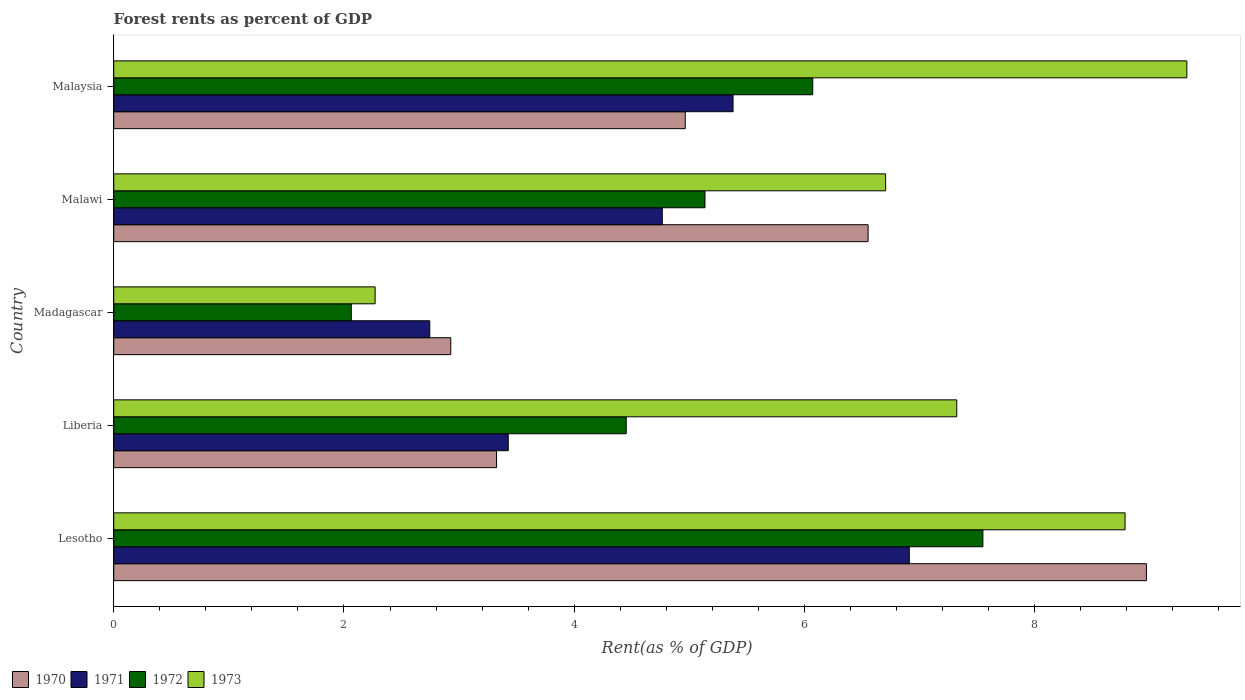How many different coloured bars are there?
Provide a succinct answer. 4. Are the number of bars on each tick of the Y-axis equal?
Make the answer very short. Yes. How many bars are there on the 1st tick from the bottom?
Make the answer very short. 4. What is the label of the 3rd group of bars from the top?
Make the answer very short. Madagascar. In how many cases, is the number of bars for a given country not equal to the number of legend labels?
Make the answer very short. 0. What is the forest rent in 1970 in Liberia?
Give a very brief answer. 3.33. Across all countries, what is the maximum forest rent in 1971?
Make the answer very short. 6.91. Across all countries, what is the minimum forest rent in 1973?
Offer a very short reply. 2.27. In which country was the forest rent in 1973 maximum?
Make the answer very short. Malaysia. In which country was the forest rent in 1973 minimum?
Make the answer very short. Madagascar. What is the total forest rent in 1973 in the graph?
Your response must be concise. 34.41. What is the difference between the forest rent in 1972 in Madagascar and that in Malaysia?
Your answer should be very brief. -4.01. What is the difference between the forest rent in 1973 in Malaysia and the forest rent in 1972 in Lesotho?
Give a very brief answer. 1.77. What is the average forest rent in 1972 per country?
Keep it short and to the point. 5.05. What is the difference between the forest rent in 1970 and forest rent in 1973 in Lesotho?
Your response must be concise. 0.19. What is the ratio of the forest rent in 1970 in Lesotho to that in Liberia?
Your response must be concise. 2.7. Is the difference between the forest rent in 1970 in Madagascar and Malawi greater than the difference between the forest rent in 1973 in Madagascar and Malawi?
Your answer should be very brief. Yes. What is the difference between the highest and the second highest forest rent in 1971?
Offer a very short reply. 1.53. What is the difference between the highest and the lowest forest rent in 1973?
Offer a terse response. 7.05. In how many countries, is the forest rent in 1971 greater than the average forest rent in 1971 taken over all countries?
Provide a succinct answer. 3. Is it the case that in every country, the sum of the forest rent in 1973 and forest rent in 1970 is greater than the sum of forest rent in 1971 and forest rent in 1972?
Your response must be concise. No. What does the 3rd bar from the bottom in Madagascar represents?
Provide a short and direct response. 1972. How many bars are there?
Ensure brevity in your answer.  20. What is the difference between two consecutive major ticks on the X-axis?
Give a very brief answer. 2. Where does the legend appear in the graph?
Your response must be concise. Bottom left. How are the legend labels stacked?
Provide a succinct answer. Horizontal. What is the title of the graph?
Your response must be concise. Forest rents as percent of GDP. Does "1968" appear as one of the legend labels in the graph?
Offer a very short reply. No. What is the label or title of the X-axis?
Offer a very short reply. Rent(as % of GDP). What is the label or title of the Y-axis?
Your answer should be compact. Country. What is the Rent(as % of GDP) in 1970 in Lesotho?
Your answer should be compact. 8.97. What is the Rent(as % of GDP) in 1971 in Lesotho?
Give a very brief answer. 6.91. What is the Rent(as % of GDP) in 1972 in Lesotho?
Provide a short and direct response. 7.55. What is the Rent(as % of GDP) of 1973 in Lesotho?
Ensure brevity in your answer.  8.79. What is the Rent(as % of GDP) in 1970 in Liberia?
Offer a very short reply. 3.33. What is the Rent(as % of GDP) of 1971 in Liberia?
Provide a short and direct response. 3.43. What is the Rent(as % of GDP) of 1972 in Liberia?
Provide a short and direct response. 4.45. What is the Rent(as % of GDP) of 1973 in Liberia?
Offer a terse response. 7.32. What is the Rent(as % of GDP) of 1970 in Madagascar?
Provide a succinct answer. 2.93. What is the Rent(as % of GDP) of 1971 in Madagascar?
Your answer should be compact. 2.75. What is the Rent(as % of GDP) of 1972 in Madagascar?
Ensure brevity in your answer.  2.06. What is the Rent(as % of GDP) of 1973 in Madagascar?
Your response must be concise. 2.27. What is the Rent(as % of GDP) in 1970 in Malawi?
Make the answer very short. 6.55. What is the Rent(as % of GDP) in 1971 in Malawi?
Your response must be concise. 4.77. What is the Rent(as % of GDP) of 1972 in Malawi?
Ensure brevity in your answer.  5.14. What is the Rent(as % of GDP) of 1973 in Malawi?
Provide a short and direct response. 6.71. What is the Rent(as % of GDP) of 1970 in Malaysia?
Provide a succinct answer. 4.96. What is the Rent(as % of GDP) of 1971 in Malaysia?
Give a very brief answer. 5.38. What is the Rent(as % of GDP) in 1972 in Malaysia?
Provide a short and direct response. 6.07. What is the Rent(as % of GDP) in 1973 in Malaysia?
Offer a terse response. 9.32. Across all countries, what is the maximum Rent(as % of GDP) in 1970?
Your answer should be very brief. 8.97. Across all countries, what is the maximum Rent(as % of GDP) of 1971?
Give a very brief answer. 6.91. Across all countries, what is the maximum Rent(as % of GDP) in 1972?
Give a very brief answer. 7.55. Across all countries, what is the maximum Rent(as % of GDP) of 1973?
Ensure brevity in your answer.  9.32. Across all countries, what is the minimum Rent(as % of GDP) of 1970?
Give a very brief answer. 2.93. Across all countries, what is the minimum Rent(as % of GDP) of 1971?
Your answer should be compact. 2.75. Across all countries, what is the minimum Rent(as % of GDP) of 1972?
Ensure brevity in your answer.  2.06. Across all countries, what is the minimum Rent(as % of GDP) in 1973?
Provide a short and direct response. 2.27. What is the total Rent(as % of GDP) of 1970 in the graph?
Ensure brevity in your answer.  26.74. What is the total Rent(as % of GDP) of 1971 in the graph?
Ensure brevity in your answer.  23.23. What is the total Rent(as % of GDP) of 1972 in the graph?
Keep it short and to the point. 25.27. What is the total Rent(as % of GDP) of 1973 in the graph?
Your answer should be compact. 34.41. What is the difference between the Rent(as % of GDP) of 1970 in Lesotho and that in Liberia?
Provide a succinct answer. 5.65. What is the difference between the Rent(as % of GDP) of 1971 in Lesotho and that in Liberia?
Give a very brief answer. 3.48. What is the difference between the Rent(as % of GDP) in 1972 in Lesotho and that in Liberia?
Your answer should be very brief. 3.1. What is the difference between the Rent(as % of GDP) of 1973 in Lesotho and that in Liberia?
Offer a terse response. 1.46. What is the difference between the Rent(as % of GDP) in 1970 in Lesotho and that in Madagascar?
Your response must be concise. 6.04. What is the difference between the Rent(as % of GDP) in 1971 in Lesotho and that in Madagascar?
Give a very brief answer. 4.17. What is the difference between the Rent(as % of GDP) of 1972 in Lesotho and that in Madagascar?
Offer a terse response. 5.49. What is the difference between the Rent(as % of GDP) of 1973 in Lesotho and that in Madagascar?
Provide a succinct answer. 6.51. What is the difference between the Rent(as % of GDP) of 1970 in Lesotho and that in Malawi?
Ensure brevity in your answer.  2.42. What is the difference between the Rent(as % of GDP) of 1971 in Lesotho and that in Malawi?
Give a very brief answer. 2.15. What is the difference between the Rent(as % of GDP) in 1972 in Lesotho and that in Malawi?
Your response must be concise. 2.41. What is the difference between the Rent(as % of GDP) in 1973 in Lesotho and that in Malawi?
Offer a terse response. 2.08. What is the difference between the Rent(as % of GDP) of 1970 in Lesotho and that in Malaysia?
Give a very brief answer. 4.01. What is the difference between the Rent(as % of GDP) in 1971 in Lesotho and that in Malaysia?
Offer a very short reply. 1.53. What is the difference between the Rent(as % of GDP) in 1972 in Lesotho and that in Malaysia?
Provide a succinct answer. 1.48. What is the difference between the Rent(as % of GDP) of 1973 in Lesotho and that in Malaysia?
Make the answer very short. -0.54. What is the difference between the Rent(as % of GDP) of 1970 in Liberia and that in Madagascar?
Your response must be concise. 0.4. What is the difference between the Rent(as % of GDP) in 1971 in Liberia and that in Madagascar?
Your answer should be compact. 0.68. What is the difference between the Rent(as % of GDP) in 1972 in Liberia and that in Madagascar?
Offer a very short reply. 2.39. What is the difference between the Rent(as % of GDP) of 1973 in Liberia and that in Madagascar?
Provide a short and direct response. 5.05. What is the difference between the Rent(as % of GDP) of 1970 in Liberia and that in Malawi?
Your response must be concise. -3.23. What is the difference between the Rent(as % of GDP) in 1971 in Liberia and that in Malawi?
Ensure brevity in your answer.  -1.34. What is the difference between the Rent(as % of GDP) in 1972 in Liberia and that in Malawi?
Provide a succinct answer. -0.68. What is the difference between the Rent(as % of GDP) in 1973 in Liberia and that in Malawi?
Your response must be concise. 0.62. What is the difference between the Rent(as % of GDP) in 1970 in Liberia and that in Malaysia?
Give a very brief answer. -1.64. What is the difference between the Rent(as % of GDP) in 1971 in Liberia and that in Malaysia?
Give a very brief answer. -1.95. What is the difference between the Rent(as % of GDP) in 1972 in Liberia and that in Malaysia?
Keep it short and to the point. -1.62. What is the difference between the Rent(as % of GDP) of 1973 in Liberia and that in Malaysia?
Provide a succinct answer. -2. What is the difference between the Rent(as % of GDP) of 1970 in Madagascar and that in Malawi?
Keep it short and to the point. -3.63. What is the difference between the Rent(as % of GDP) of 1971 in Madagascar and that in Malawi?
Your answer should be compact. -2.02. What is the difference between the Rent(as % of GDP) of 1972 in Madagascar and that in Malawi?
Offer a very short reply. -3.07. What is the difference between the Rent(as % of GDP) of 1973 in Madagascar and that in Malawi?
Your answer should be very brief. -4.43. What is the difference between the Rent(as % of GDP) in 1970 in Madagascar and that in Malaysia?
Your answer should be compact. -2.04. What is the difference between the Rent(as % of GDP) in 1971 in Madagascar and that in Malaysia?
Ensure brevity in your answer.  -2.63. What is the difference between the Rent(as % of GDP) in 1972 in Madagascar and that in Malaysia?
Provide a succinct answer. -4.01. What is the difference between the Rent(as % of GDP) of 1973 in Madagascar and that in Malaysia?
Your answer should be compact. -7.05. What is the difference between the Rent(as % of GDP) in 1970 in Malawi and that in Malaysia?
Provide a succinct answer. 1.59. What is the difference between the Rent(as % of GDP) in 1971 in Malawi and that in Malaysia?
Keep it short and to the point. -0.61. What is the difference between the Rent(as % of GDP) of 1972 in Malawi and that in Malaysia?
Offer a very short reply. -0.94. What is the difference between the Rent(as % of GDP) in 1973 in Malawi and that in Malaysia?
Offer a very short reply. -2.62. What is the difference between the Rent(as % of GDP) in 1970 in Lesotho and the Rent(as % of GDP) in 1971 in Liberia?
Offer a terse response. 5.54. What is the difference between the Rent(as % of GDP) of 1970 in Lesotho and the Rent(as % of GDP) of 1972 in Liberia?
Give a very brief answer. 4.52. What is the difference between the Rent(as % of GDP) of 1970 in Lesotho and the Rent(as % of GDP) of 1973 in Liberia?
Give a very brief answer. 1.65. What is the difference between the Rent(as % of GDP) in 1971 in Lesotho and the Rent(as % of GDP) in 1972 in Liberia?
Make the answer very short. 2.46. What is the difference between the Rent(as % of GDP) of 1971 in Lesotho and the Rent(as % of GDP) of 1973 in Liberia?
Keep it short and to the point. -0.41. What is the difference between the Rent(as % of GDP) of 1972 in Lesotho and the Rent(as % of GDP) of 1973 in Liberia?
Offer a terse response. 0.23. What is the difference between the Rent(as % of GDP) in 1970 in Lesotho and the Rent(as % of GDP) in 1971 in Madagascar?
Offer a very short reply. 6.23. What is the difference between the Rent(as % of GDP) of 1970 in Lesotho and the Rent(as % of GDP) of 1972 in Madagascar?
Offer a terse response. 6.91. What is the difference between the Rent(as % of GDP) in 1970 in Lesotho and the Rent(as % of GDP) in 1973 in Madagascar?
Give a very brief answer. 6.7. What is the difference between the Rent(as % of GDP) of 1971 in Lesotho and the Rent(as % of GDP) of 1972 in Madagascar?
Offer a very short reply. 4.85. What is the difference between the Rent(as % of GDP) of 1971 in Lesotho and the Rent(as % of GDP) of 1973 in Madagascar?
Offer a terse response. 4.64. What is the difference between the Rent(as % of GDP) in 1972 in Lesotho and the Rent(as % of GDP) in 1973 in Madagascar?
Provide a short and direct response. 5.28. What is the difference between the Rent(as % of GDP) of 1970 in Lesotho and the Rent(as % of GDP) of 1971 in Malawi?
Ensure brevity in your answer.  4.21. What is the difference between the Rent(as % of GDP) in 1970 in Lesotho and the Rent(as % of GDP) in 1972 in Malawi?
Offer a terse response. 3.83. What is the difference between the Rent(as % of GDP) of 1970 in Lesotho and the Rent(as % of GDP) of 1973 in Malawi?
Your response must be concise. 2.27. What is the difference between the Rent(as % of GDP) in 1971 in Lesotho and the Rent(as % of GDP) in 1972 in Malawi?
Provide a short and direct response. 1.78. What is the difference between the Rent(as % of GDP) in 1971 in Lesotho and the Rent(as % of GDP) in 1973 in Malawi?
Offer a very short reply. 0.21. What is the difference between the Rent(as % of GDP) in 1972 in Lesotho and the Rent(as % of GDP) in 1973 in Malawi?
Keep it short and to the point. 0.85. What is the difference between the Rent(as % of GDP) of 1970 in Lesotho and the Rent(as % of GDP) of 1971 in Malaysia?
Offer a terse response. 3.59. What is the difference between the Rent(as % of GDP) of 1970 in Lesotho and the Rent(as % of GDP) of 1972 in Malaysia?
Your answer should be compact. 2.9. What is the difference between the Rent(as % of GDP) of 1970 in Lesotho and the Rent(as % of GDP) of 1973 in Malaysia?
Offer a terse response. -0.35. What is the difference between the Rent(as % of GDP) in 1971 in Lesotho and the Rent(as % of GDP) in 1972 in Malaysia?
Provide a succinct answer. 0.84. What is the difference between the Rent(as % of GDP) in 1971 in Lesotho and the Rent(as % of GDP) in 1973 in Malaysia?
Offer a very short reply. -2.41. What is the difference between the Rent(as % of GDP) in 1972 in Lesotho and the Rent(as % of GDP) in 1973 in Malaysia?
Your response must be concise. -1.77. What is the difference between the Rent(as % of GDP) of 1970 in Liberia and the Rent(as % of GDP) of 1971 in Madagascar?
Ensure brevity in your answer.  0.58. What is the difference between the Rent(as % of GDP) in 1970 in Liberia and the Rent(as % of GDP) in 1972 in Madagascar?
Give a very brief answer. 1.26. What is the difference between the Rent(as % of GDP) in 1970 in Liberia and the Rent(as % of GDP) in 1973 in Madagascar?
Provide a short and direct response. 1.05. What is the difference between the Rent(as % of GDP) in 1971 in Liberia and the Rent(as % of GDP) in 1972 in Madagascar?
Give a very brief answer. 1.36. What is the difference between the Rent(as % of GDP) in 1971 in Liberia and the Rent(as % of GDP) in 1973 in Madagascar?
Provide a succinct answer. 1.16. What is the difference between the Rent(as % of GDP) in 1972 in Liberia and the Rent(as % of GDP) in 1973 in Madagascar?
Offer a very short reply. 2.18. What is the difference between the Rent(as % of GDP) in 1970 in Liberia and the Rent(as % of GDP) in 1971 in Malawi?
Offer a terse response. -1.44. What is the difference between the Rent(as % of GDP) in 1970 in Liberia and the Rent(as % of GDP) in 1972 in Malawi?
Your response must be concise. -1.81. What is the difference between the Rent(as % of GDP) in 1970 in Liberia and the Rent(as % of GDP) in 1973 in Malawi?
Your response must be concise. -3.38. What is the difference between the Rent(as % of GDP) in 1971 in Liberia and the Rent(as % of GDP) in 1972 in Malawi?
Your response must be concise. -1.71. What is the difference between the Rent(as % of GDP) of 1971 in Liberia and the Rent(as % of GDP) of 1973 in Malawi?
Make the answer very short. -3.28. What is the difference between the Rent(as % of GDP) of 1972 in Liberia and the Rent(as % of GDP) of 1973 in Malawi?
Your answer should be very brief. -2.25. What is the difference between the Rent(as % of GDP) of 1970 in Liberia and the Rent(as % of GDP) of 1971 in Malaysia?
Your answer should be very brief. -2.05. What is the difference between the Rent(as % of GDP) in 1970 in Liberia and the Rent(as % of GDP) in 1972 in Malaysia?
Your answer should be very brief. -2.75. What is the difference between the Rent(as % of GDP) in 1970 in Liberia and the Rent(as % of GDP) in 1973 in Malaysia?
Provide a short and direct response. -6. What is the difference between the Rent(as % of GDP) of 1971 in Liberia and the Rent(as % of GDP) of 1972 in Malaysia?
Your answer should be very brief. -2.65. What is the difference between the Rent(as % of GDP) of 1971 in Liberia and the Rent(as % of GDP) of 1973 in Malaysia?
Provide a succinct answer. -5.89. What is the difference between the Rent(as % of GDP) of 1972 in Liberia and the Rent(as % of GDP) of 1973 in Malaysia?
Ensure brevity in your answer.  -4.87. What is the difference between the Rent(as % of GDP) in 1970 in Madagascar and the Rent(as % of GDP) in 1971 in Malawi?
Ensure brevity in your answer.  -1.84. What is the difference between the Rent(as % of GDP) of 1970 in Madagascar and the Rent(as % of GDP) of 1972 in Malawi?
Your response must be concise. -2.21. What is the difference between the Rent(as % of GDP) of 1970 in Madagascar and the Rent(as % of GDP) of 1973 in Malawi?
Keep it short and to the point. -3.78. What is the difference between the Rent(as % of GDP) of 1971 in Madagascar and the Rent(as % of GDP) of 1972 in Malawi?
Provide a succinct answer. -2.39. What is the difference between the Rent(as % of GDP) in 1971 in Madagascar and the Rent(as % of GDP) in 1973 in Malawi?
Ensure brevity in your answer.  -3.96. What is the difference between the Rent(as % of GDP) in 1972 in Madagascar and the Rent(as % of GDP) in 1973 in Malawi?
Give a very brief answer. -4.64. What is the difference between the Rent(as % of GDP) in 1970 in Madagascar and the Rent(as % of GDP) in 1971 in Malaysia?
Your response must be concise. -2.45. What is the difference between the Rent(as % of GDP) of 1970 in Madagascar and the Rent(as % of GDP) of 1972 in Malaysia?
Your response must be concise. -3.14. What is the difference between the Rent(as % of GDP) in 1970 in Madagascar and the Rent(as % of GDP) in 1973 in Malaysia?
Ensure brevity in your answer.  -6.39. What is the difference between the Rent(as % of GDP) of 1971 in Madagascar and the Rent(as % of GDP) of 1972 in Malaysia?
Offer a very short reply. -3.33. What is the difference between the Rent(as % of GDP) of 1971 in Madagascar and the Rent(as % of GDP) of 1973 in Malaysia?
Ensure brevity in your answer.  -6.58. What is the difference between the Rent(as % of GDP) of 1972 in Madagascar and the Rent(as % of GDP) of 1973 in Malaysia?
Your response must be concise. -7.26. What is the difference between the Rent(as % of GDP) in 1970 in Malawi and the Rent(as % of GDP) in 1971 in Malaysia?
Keep it short and to the point. 1.17. What is the difference between the Rent(as % of GDP) in 1970 in Malawi and the Rent(as % of GDP) in 1972 in Malaysia?
Offer a terse response. 0.48. What is the difference between the Rent(as % of GDP) of 1970 in Malawi and the Rent(as % of GDP) of 1973 in Malaysia?
Provide a succinct answer. -2.77. What is the difference between the Rent(as % of GDP) of 1971 in Malawi and the Rent(as % of GDP) of 1972 in Malaysia?
Your answer should be very brief. -1.31. What is the difference between the Rent(as % of GDP) in 1971 in Malawi and the Rent(as % of GDP) in 1973 in Malaysia?
Offer a terse response. -4.56. What is the difference between the Rent(as % of GDP) in 1972 in Malawi and the Rent(as % of GDP) in 1973 in Malaysia?
Provide a succinct answer. -4.19. What is the average Rent(as % of GDP) of 1970 per country?
Provide a succinct answer. 5.35. What is the average Rent(as % of GDP) in 1971 per country?
Keep it short and to the point. 4.65. What is the average Rent(as % of GDP) of 1972 per country?
Provide a short and direct response. 5.05. What is the average Rent(as % of GDP) of 1973 per country?
Make the answer very short. 6.88. What is the difference between the Rent(as % of GDP) of 1970 and Rent(as % of GDP) of 1971 in Lesotho?
Your answer should be compact. 2.06. What is the difference between the Rent(as % of GDP) in 1970 and Rent(as % of GDP) in 1972 in Lesotho?
Give a very brief answer. 1.42. What is the difference between the Rent(as % of GDP) in 1970 and Rent(as % of GDP) in 1973 in Lesotho?
Your response must be concise. 0.19. What is the difference between the Rent(as % of GDP) in 1971 and Rent(as % of GDP) in 1972 in Lesotho?
Make the answer very short. -0.64. What is the difference between the Rent(as % of GDP) in 1971 and Rent(as % of GDP) in 1973 in Lesotho?
Provide a succinct answer. -1.87. What is the difference between the Rent(as % of GDP) in 1972 and Rent(as % of GDP) in 1973 in Lesotho?
Provide a succinct answer. -1.24. What is the difference between the Rent(as % of GDP) of 1970 and Rent(as % of GDP) of 1971 in Liberia?
Your answer should be compact. -0.1. What is the difference between the Rent(as % of GDP) of 1970 and Rent(as % of GDP) of 1972 in Liberia?
Keep it short and to the point. -1.13. What is the difference between the Rent(as % of GDP) of 1970 and Rent(as % of GDP) of 1973 in Liberia?
Offer a terse response. -4. What is the difference between the Rent(as % of GDP) of 1971 and Rent(as % of GDP) of 1972 in Liberia?
Make the answer very short. -1.02. What is the difference between the Rent(as % of GDP) in 1971 and Rent(as % of GDP) in 1973 in Liberia?
Your answer should be compact. -3.9. What is the difference between the Rent(as % of GDP) of 1972 and Rent(as % of GDP) of 1973 in Liberia?
Your answer should be compact. -2.87. What is the difference between the Rent(as % of GDP) in 1970 and Rent(as % of GDP) in 1971 in Madagascar?
Your answer should be very brief. 0.18. What is the difference between the Rent(as % of GDP) of 1970 and Rent(as % of GDP) of 1972 in Madagascar?
Offer a very short reply. 0.86. What is the difference between the Rent(as % of GDP) of 1970 and Rent(as % of GDP) of 1973 in Madagascar?
Ensure brevity in your answer.  0.66. What is the difference between the Rent(as % of GDP) of 1971 and Rent(as % of GDP) of 1972 in Madagascar?
Provide a short and direct response. 0.68. What is the difference between the Rent(as % of GDP) of 1971 and Rent(as % of GDP) of 1973 in Madagascar?
Keep it short and to the point. 0.47. What is the difference between the Rent(as % of GDP) of 1972 and Rent(as % of GDP) of 1973 in Madagascar?
Provide a succinct answer. -0.21. What is the difference between the Rent(as % of GDP) in 1970 and Rent(as % of GDP) in 1971 in Malawi?
Make the answer very short. 1.79. What is the difference between the Rent(as % of GDP) of 1970 and Rent(as % of GDP) of 1972 in Malawi?
Provide a succinct answer. 1.42. What is the difference between the Rent(as % of GDP) of 1970 and Rent(as % of GDP) of 1973 in Malawi?
Offer a very short reply. -0.15. What is the difference between the Rent(as % of GDP) of 1971 and Rent(as % of GDP) of 1972 in Malawi?
Your answer should be compact. -0.37. What is the difference between the Rent(as % of GDP) of 1971 and Rent(as % of GDP) of 1973 in Malawi?
Offer a terse response. -1.94. What is the difference between the Rent(as % of GDP) in 1972 and Rent(as % of GDP) in 1973 in Malawi?
Give a very brief answer. -1.57. What is the difference between the Rent(as % of GDP) in 1970 and Rent(as % of GDP) in 1971 in Malaysia?
Your answer should be very brief. -0.42. What is the difference between the Rent(as % of GDP) of 1970 and Rent(as % of GDP) of 1972 in Malaysia?
Your answer should be very brief. -1.11. What is the difference between the Rent(as % of GDP) in 1970 and Rent(as % of GDP) in 1973 in Malaysia?
Provide a short and direct response. -4.36. What is the difference between the Rent(as % of GDP) in 1971 and Rent(as % of GDP) in 1972 in Malaysia?
Your response must be concise. -0.69. What is the difference between the Rent(as % of GDP) of 1971 and Rent(as % of GDP) of 1973 in Malaysia?
Keep it short and to the point. -3.94. What is the difference between the Rent(as % of GDP) in 1972 and Rent(as % of GDP) in 1973 in Malaysia?
Provide a succinct answer. -3.25. What is the ratio of the Rent(as % of GDP) of 1970 in Lesotho to that in Liberia?
Your response must be concise. 2.7. What is the ratio of the Rent(as % of GDP) of 1971 in Lesotho to that in Liberia?
Ensure brevity in your answer.  2.02. What is the ratio of the Rent(as % of GDP) in 1972 in Lesotho to that in Liberia?
Ensure brevity in your answer.  1.7. What is the ratio of the Rent(as % of GDP) in 1973 in Lesotho to that in Liberia?
Your response must be concise. 1.2. What is the ratio of the Rent(as % of GDP) of 1970 in Lesotho to that in Madagascar?
Make the answer very short. 3.06. What is the ratio of the Rent(as % of GDP) of 1971 in Lesotho to that in Madagascar?
Give a very brief answer. 2.52. What is the ratio of the Rent(as % of GDP) in 1972 in Lesotho to that in Madagascar?
Make the answer very short. 3.66. What is the ratio of the Rent(as % of GDP) of 1973 in Lesotho to that in Madagascar?
Your answer should be compact. 3.87. What is the ratio of the Rent(as % of GDP) in 1970 in Lesotho to that in Malawi?
Ensure brevity in your answer.  1.37. What is the ratio of the Rent(as % of GDP) in 1971 in Lesotho to that in Malawi?
Provide a succinct answer. 1.45. What is the ratio of the Rent(as % of GDP) of 1972 in Lesotho to that in Malawi?
Provide a succinct answer. 1.47. What is the ratio of the Rent(as % of GDP) in 1973 in Lesotho to that in Malawi?
Provide a succinct answer. 1.31. What is the ratio of the Rent(as % of GDP) in 1970 in Lesotho to that in Malaysia?
Make the answer very short. 1.81. What is the ratio of the Rent(as % of GDP) of 1971 in Lesotho to that in Malaysia?
Give a very brief answer. 1.28. What is the ratio of the Rent(as % of GDP) of 1972 in Lesotho to that in Malaysia?
Your answer should be compact. 1.24. What is the ratio of the Rent(as % of GDP) in 1973 in Lesotho to that in Malaysia?
Your answer should be compact. 0.94. What is the ratio of the Rent(as % of GDP) of 1970 in Liberia to that in Madagascar?
Provide a short and direct response. 1.14. What is the ratio of the Rent(as % of GDP) in 1971 in Liberia to that in Madagascar?
Your answer should be very brief. 1.25. What is the ratio of the Rent(as % of GDP) in 1972 in Liberia to that in Madagascar?
Your answer should be very brief. 2.16. What is the ratio of the Rent(as % of GDP) of 1973 in Liberia to that in Madagascar?
Keep it short and to the point. 3.23. What is the ratio of the Rent(as % of GDP) in 1970 in Liberia to that in Malawi?
Your response must be concise. 0.51. What is the ratio of the Rent(as % of GDP) in 1971 in Liberia to that in Malawi?
Your answer should be very brief. 0.72. What is the ratio of the Rent(as % of GDP) of 1972 in Liberia to that in Malawi?
Provide a succinct answer. 0.87. What is the ratio of the Rent(as % of GDP) of 1973 in Liberia to that in Malawi?
Your answer should be compact. 1.09. What is the ratio of the Rent(as % of GDP) of 1970 in Liberia to that in Malaysia?
Keep it short and to the point. 0.67. What is the ratio of the Rent(as % of GDP) of 1971 in Liberia to that in Malaysia?
Provide a short and direct response. 0.64. What is the ratio of the Rent(as % of GDP) of 1972 in Liberia to that in Malaysia?
Make the answer very short. 0.73. What is the ratio of the Rent(as % of GDP) of 1973 in Liberia to that in Malaysia?
Your answer should be compact. 0.79. What is the ratio of the Rent(as % of GDP) in 1970 in Madagascar to that in Malawi?
Offer a very short reply. 0.45. What is the ratio of the Rent(as % of GDP) of 1971 in Madagascar to that in Malawi?
Offer a very short reply. 0.58. What is the ratio of the Rent(as % of GDP) of 1972 in Madagascar to that in Malawi?
Give a very brief answer. 0.4. What is the ratio of the Rent(as % of GDP) of 1973 in Madagascar to that in Malawi?
Make the answer very short. 0.34. What is the ratio of the Rent(as % of GDP) of 1970 in Madagascar to that in Malaysia?
Offer a terse response. 0.59. What is the ratio of the Rent(as % of GDP) of 1971 in Madagascar to that in Malaysia?
Your response must be concise. 0.51. What is the ratio of the Rent(as % of GDP) of 1972 in Madagascar to that in Malaysia?
Make the answer very short. 0.34. What is the ratio of the Rent(as % of GDP) in 1973 in Madagascar to that in Malaysia?
Offer a very short reply. 0.24. What is the ratio of the Rent(as % of GDP) of 1970 in Malawi to that in Malaysia?
Make the answer very short. 1.32. What is the ratio of the Rent(as % of GDP) in 1971 in Malawi to that in Malaysia?
Give a very brief answer. 0.89. What is the ratio of the Rent(as % of GDP) in 1972 in Malawi to that in Malaysia?
Your answer should be compact. 0.85. What is the ratio of the Rent(as % of GDP) of 1973 in Malawi to that in Malaysia?
Offer a very short reply. 0.72. What is the difference between the highest and the second highest Rent(as % of GDP) in 1970?
Your response must be concise. 2.42. What is the difference between the highest and the second highest Rent(as % of GDP) in 1971?
Keep it short and to the point. 1.53. What is the difference between the highest and the second highest Rent(as % of GDP) of 1972?
Make the answer very short. 1.48. What is the difference between the highest and the second highest Rent(as % of GDP) in 1973?
Give a very brief answer. 0.54. What is the difference between the highest and the lowest Rent(as % of GDP) of 1970?
Your response must be concise. 6.04. What is the difference between the highest and the lowest Rent(as % of GDP) in 1971?
Ensure brevity in your answer.  4.17. What is the difference between the highest and the lowest Rent(as % of GDP) in 1972?
Your answer should be compact. 5.49. What is the difference between the highest and the lowest Rent(as % of GDP) in 1973?
Ensure brevity in your answer.  7.05. 